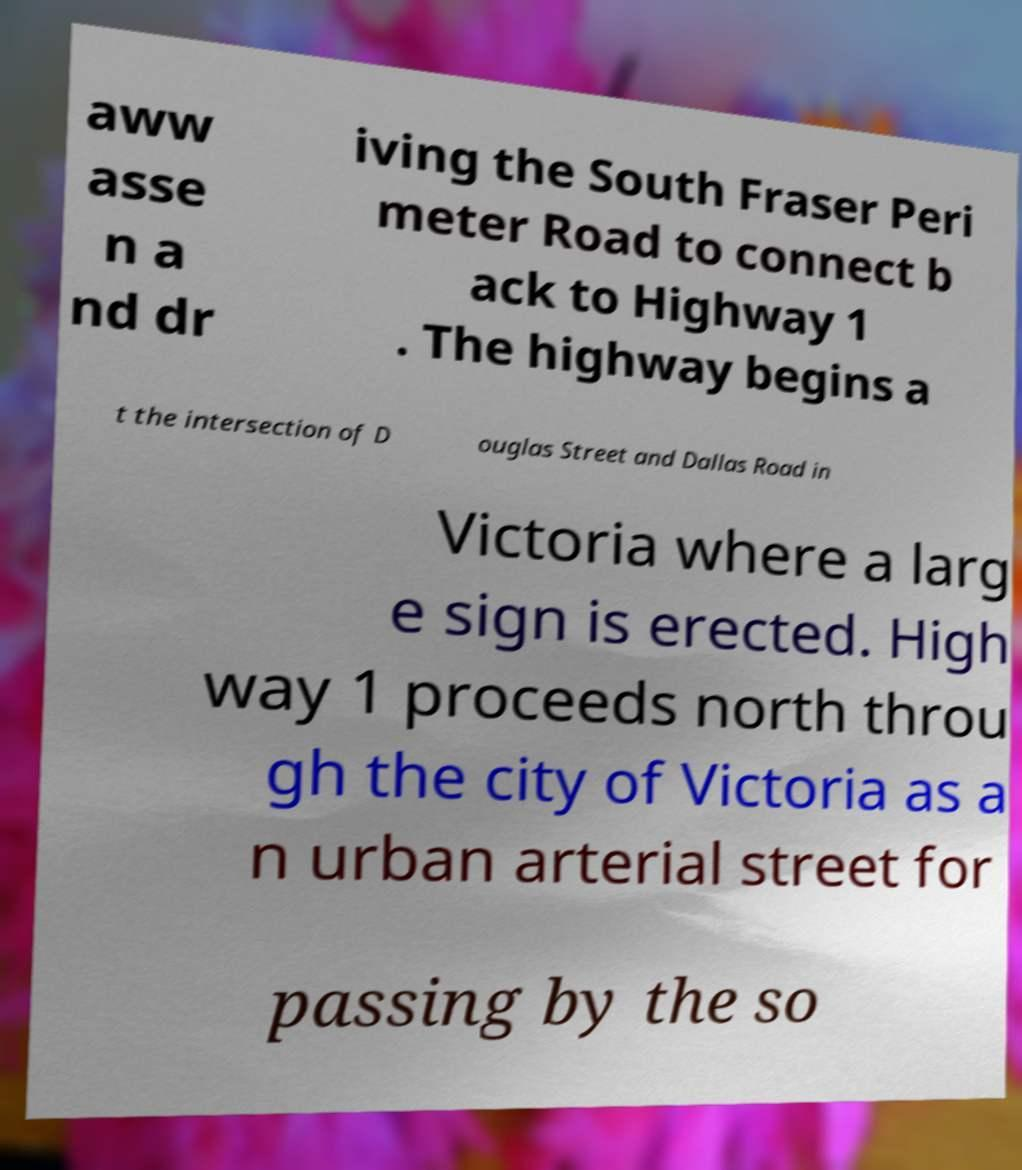For documentation purposes, I need the text within this image transcribed. Could you provide that? aww asse n a nd dr iving the South Fraser Peri meter Road to connect b ack to Highway 1 . The highway begins a t the intersection of D ouglas Street and Dallas Road in Victoria where a larg e sign is erected. High way 1 proceeds north throu gh the city of Victoria as a n urban arterial street for passing by the so 